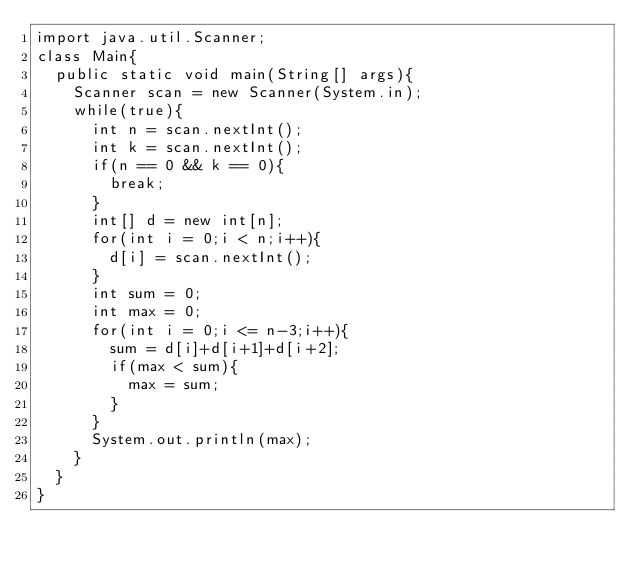Convert code to text. <code><loc_0><loc_0><loc_500><loc_500><_Java_>import java.util.Scanner;
class Main{
	public static void main(String[] args){
		Scanner scan = new Scanner(System.in);
		while(true){
			int n = scan.nextInt();
			int k = scan.nextInt();
			if(n == 0 && k == 0){
				break;
			}
			int[] d = new int[n];
			for(int i = 0;i < n;i++){
				d[i] = scan.nextInt();
			}
			int sum = 0;
			int max = 0;
			for(int i = 0;i <= n-3;i++){
				sum = d[i]+d[i+1]+d[i+2];
				if(max < sum){
					max = sum;
				}
			}
			System.out.println(max);
		}
	}
}</code> 